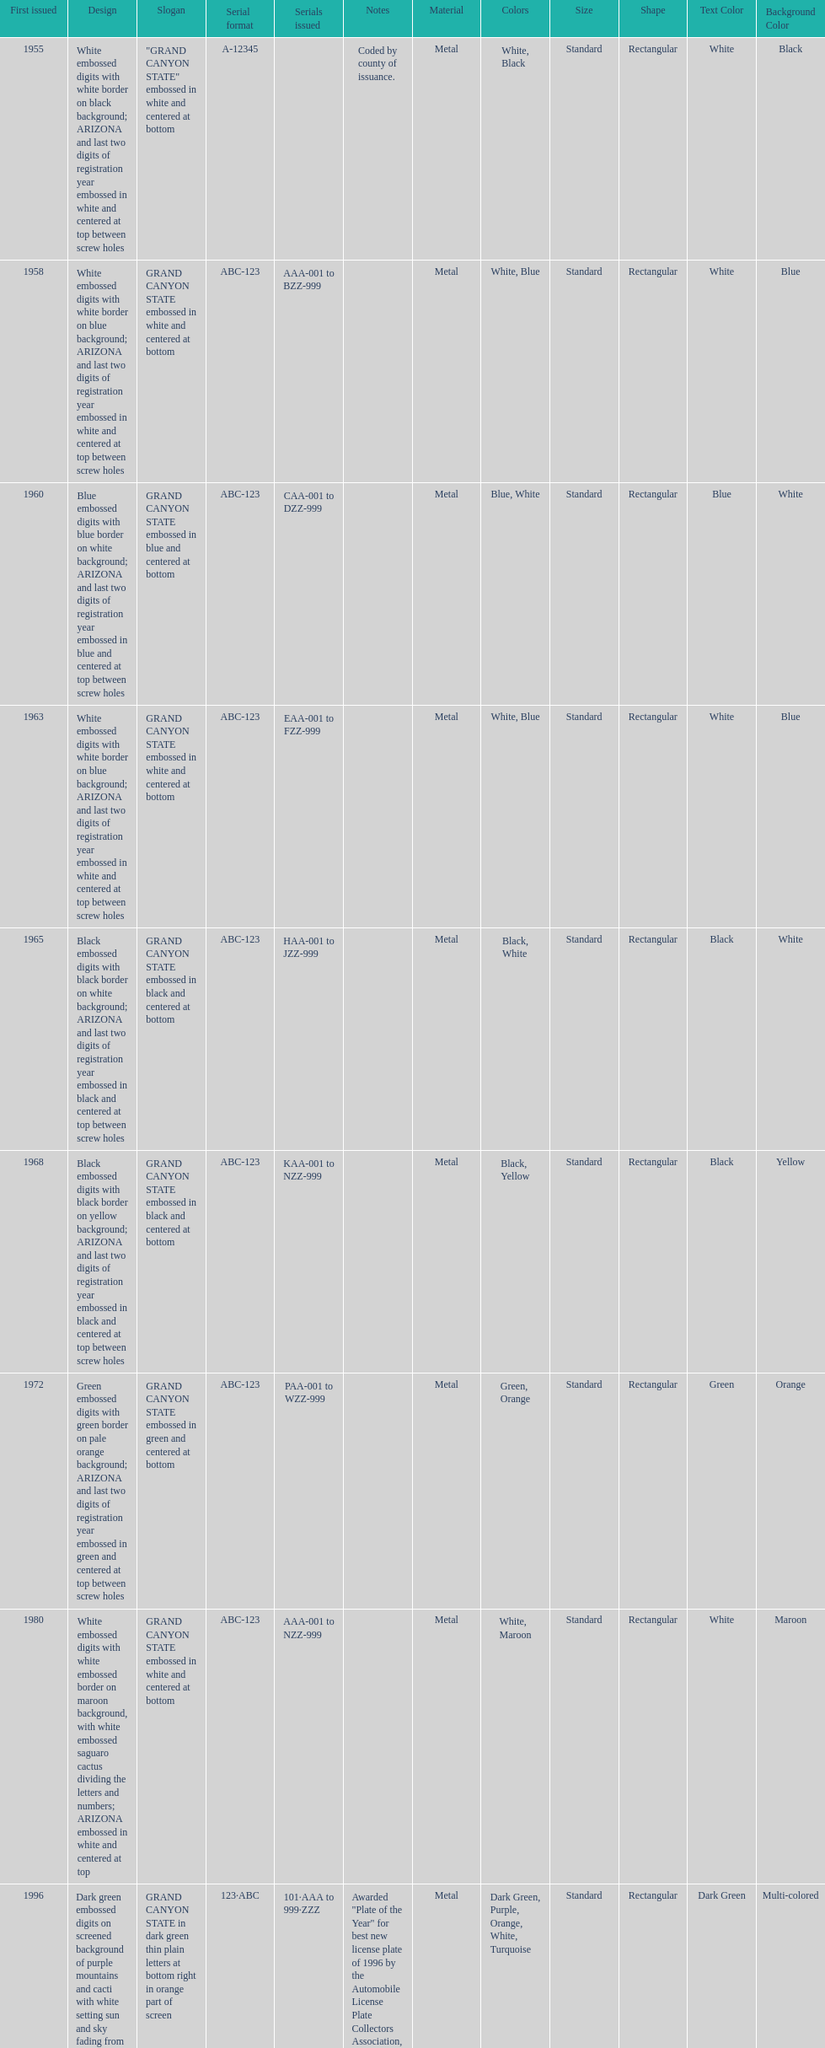What is the average serial format of the arizona license plates? ABC-123. 